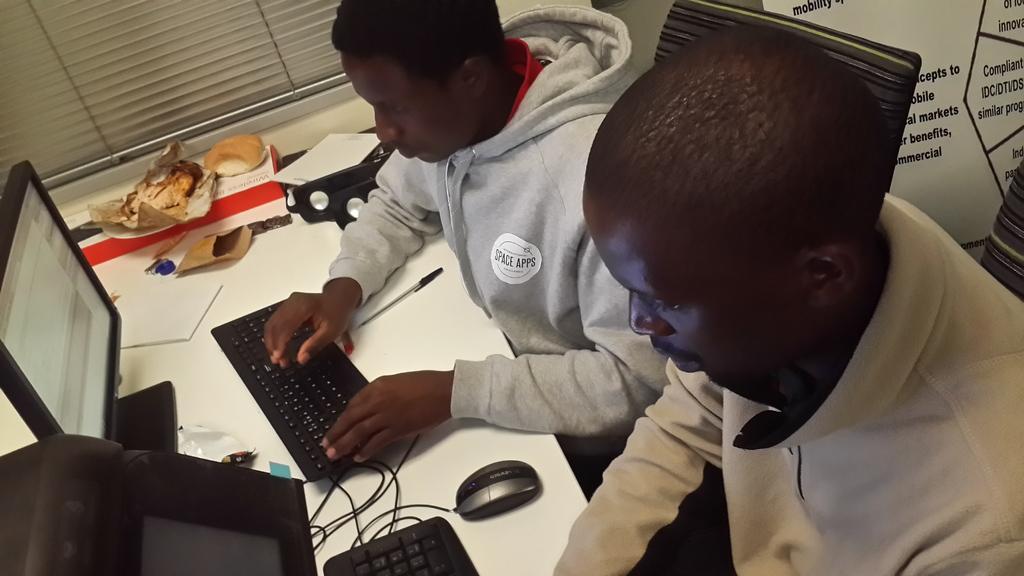Please provide a concise description of this image. In the background we can see a window blind. In this picture we can see men sitting on the chairs. On a table we can see monitor, keyboard, mouse, pen and few objects. On the right side of the picture we can see a board with some information. 